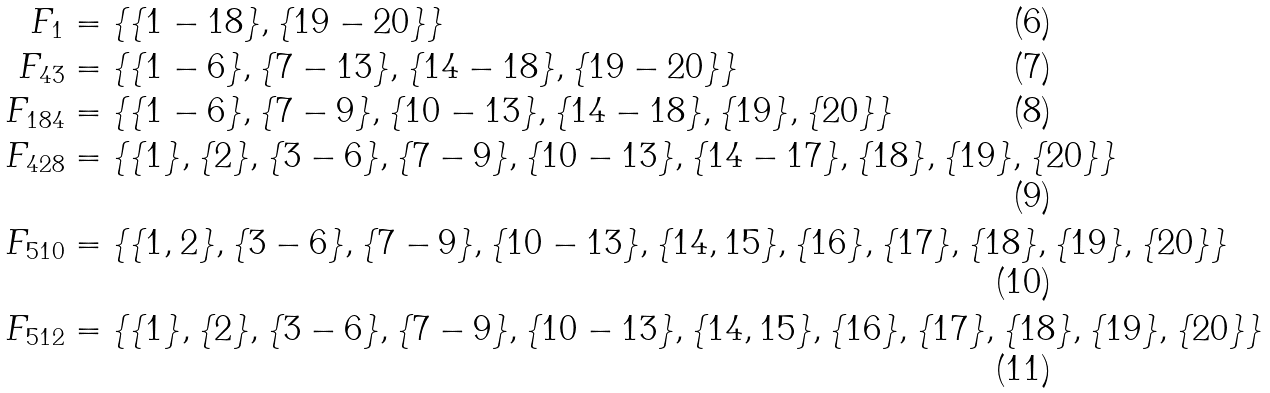<formula> <loc_0><loc_0><loc_500><loc_500>F _ { 1 } & = \{ \{ 1 - 1 8 \} , \{ 1 9 - 2 0 \} \} \\ F _ { 4 3 } & = \{ \{ 1 - 6 \} , \{ 7 - 1 3 \} , \{ 1 4 - 1 8 \} , \{ 1 9 - 2 0 \} \} \\ F _ { 1 8 4 } & = \{ \{ 1 - 6 \} , \{ 7 - 9 \} , \{ 1 0 - 1 3 \} , \{ 1 4 - 1 8 \} , \{ 1 9 \} , \{ 2 0 \} \} \\ F _ { 4 2 8 } & = \{ \{ 1 \} , \{ 2 \} , \{ 3 - 6 \} , \{ 7 - 9 \} , \{ 1 0 - 1 3 \} , \{ 1 4 - 1 7 \} , \{ 1 8 \} , \{ 1 9 \} , \{ 2 0 \} \} \\ F _ { 5 1 0 } & = \{ \{ 1 , 2 \} , \{ 3 - 6 \} , \{ 7 - 9 \} , \{ 1 0 - 1 3 \} , \{ 1 4 , 1 5 \} , \{ 1 6 \} , \{ 1 7 \} , \{ 1 8 \} , \{ 1 9 \} , \{ 2 0 \} \} \\ F _ { 5 1 2 } & = \{ \{ 1 \} , \{ 2 \} , \{ 3 - 6 \} , \{ 7 - 9 \} , \{ 1 0 - 1 3 \} , \{ 1 4 , 1 5 \} , \{ 1 6 \} , \{ 1 7 \} , \{ 1 8 \} , \{ 1 9 \} , \{ 2 0 \} \}</formula> 